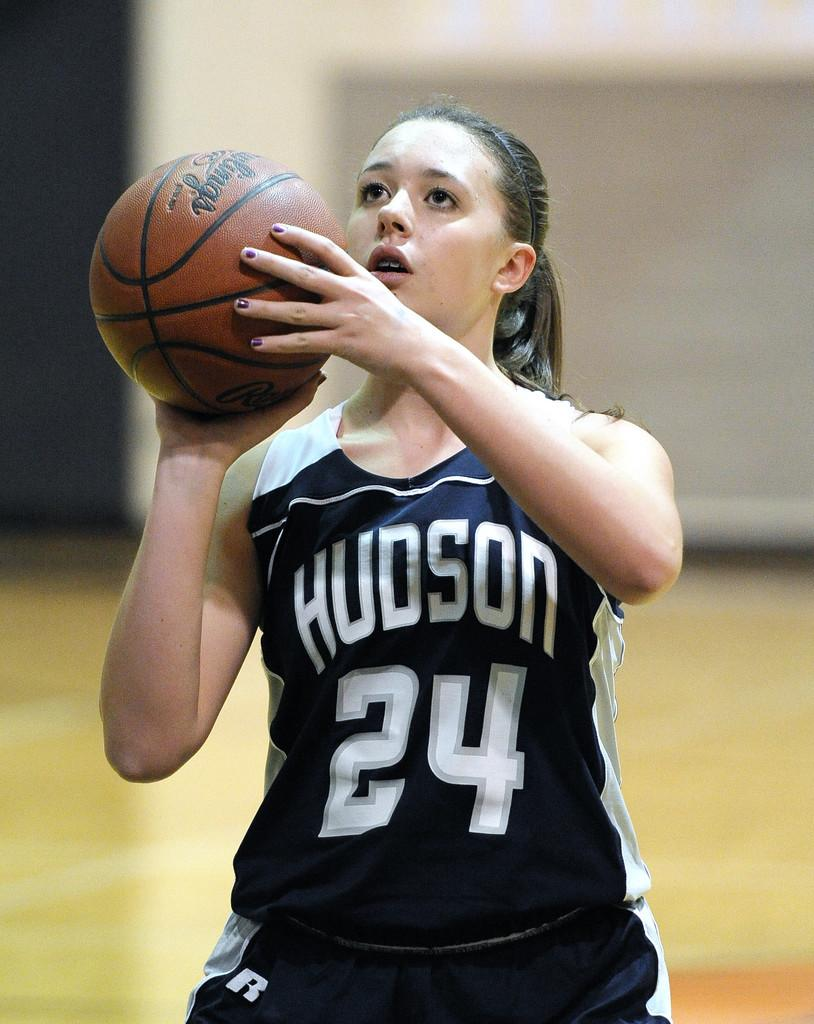<image>
Describe the image concisely. Basketball player wearing a jersey that says Hudson. 